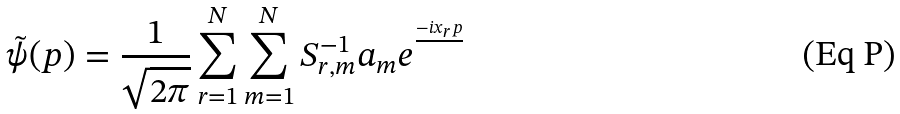Convert formula to latex. <formula><loc_0><loc_0><loc_500><loc_500>\tilde { \psi } ( p ) = \frac { 1 } { \sqrt { 2 \pi } } \sum _ { r = 1 } ^ { N } \sum _ { m = 1 } ^ { N } S ^ { - 1 } _ { r , m } a _ { m } e ^ { \frac { - i x _ { r } p } { } }</formula> 